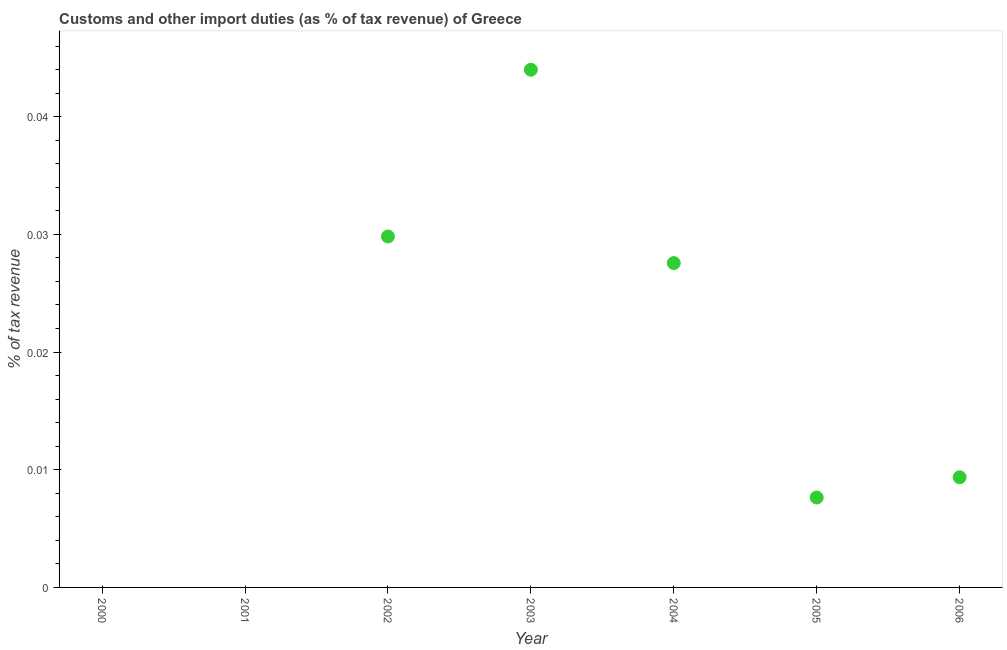What is the customs and other import duties in 2005?
Make the answer very short. 0.01. Across all years, what is the maximum customs and other import duties?
Provide a succinct answer. 0.04. In which year was the customs and other import duties maximum?
Your answer should be very brief. 2003. What is the sum of the customs and other import duties?
Make the answer very short. 0.12. What is the difference between the customs and other import duties in 2003 and 2005?
Keep it short and to the point. 0.04. What is the average customs and other import duties per year?
Ensure brevity in your answer.  0.02. What is the median customs and other import duties?
Keep it short and to the point. 0.01. What is the ratio of the customs and other import duties in 2005 to that in 2006?
Ensure brevity in your answer.  0.82. Is the customs and other import duties in 2005 less than that in 2006?
Your answer should be very brief. Yes. What is the difference between the highest and the second highest customs and other import duties?
Provide a short and direct response. 0.01. Is the sum of the customs and other import duties in 2003 and 2004 greater than the maximum customs and other import duties across all years?
Your response must be concise. Yes. What is the difference between the highest and the lowest customs and other import duties?
Provide a short and direct response. 0.04. What is the difference between two consecutive major ticks on the Y-axis?
Provide a short and direct response. 0.01. Does the graph contain any zero values?
Make the answer very short. Yes. Does the graph contain grids?
Give a very brief answer. No. What is the title of the graph?
Provide a succinct answer. Customs and other import duties (as % of tax revenue) of Greece. What is the label or title of the Y-axis?
Provide a short and direct response. % of tax revenue. What is the % of tax revenue in 2000?
Offer a terse response. 0. What is the % of tax revenue in 2001?
Give a very brief answer. 0. What is the % of tax revenue in 2002?
Provide a succinct answer. 0.03. What is the % of tax revenue in 2003?
Offer a terse response. 0.04. What is the % of tax revenue in 2004?
Offer a very short reply. 0.03. What is the % of tax revenue in 2005?
Your answer should be compact. 0.01. What is the % of tax revenue in 2006?
Provide a short and direct response. 0.01. What is the difference between the % of tax revenue in 2002 and 2003?
Make the answer very short. -0.01. What is the difference between the % of tax revenue in 2002 and 2004?
Keep it short and to the point. 0. What is the difference between the % of tax revenue in 2002 and 2005?
Your answer should be compact. 0.02. What is the difference between the % of tax revenue in 2002 and 2006?
Ensure brevity in your answer.  0.02. What is the difference between the % of tax revenue in 2003 and 2004?
Keep it short and to the point. 0.02. What is the difference between the % of tax revenue in 2003 and 2005?
Keep it short and to the point. 0.04. What is the difference between the % of tax revenue in 2003 and 2006?
Make the answer very short. 0.03. What is the difference between the % of tax revenue in 2004 and 2005?
Make the answer very short. 0.02. What is the difference between the % of tax revenue in 2004 and 2006?
Ensure brevity in your answer.  0.02. What is the difference between the % of tax revenue in 2005 and 2006?
Ensure brevity in your answer.  -0. What is the ratio of the % of tax revenue in 2002 to that in 2003?
Your response must be concise. 0.68. What is the ratio of the % of tax revenue in 2002 to that in 2004?
Ensure brevity in your answer.  1.08. What is the ratio of the % of tax revenue in 2002 to that in 2005?
Provide a succinct answer. 3.9. What is the ratio of the % of tax revenue in 2002 to that in 2006?
Offer a terse response. 3.19. What is the ratio of the % of tax revenue in 2003 to that in 2004?
Give a very brief answer. 1.6. What is the ratio of the % of tax revenue in 2003 to that in 2005?
Provide a short and direct response. 5.76. What is the ratio of the % of tax revenue in 2004 to that in 2005?
Offer a very short reply. 3.61. What is the ratio of the % of tax revenue in 2004 to that in 2006?
Make the answer very short. 2.94. What is the ratio of the % of tax revenue in 2005 to that in 2006?
Offer a very short reply. 0.82. 